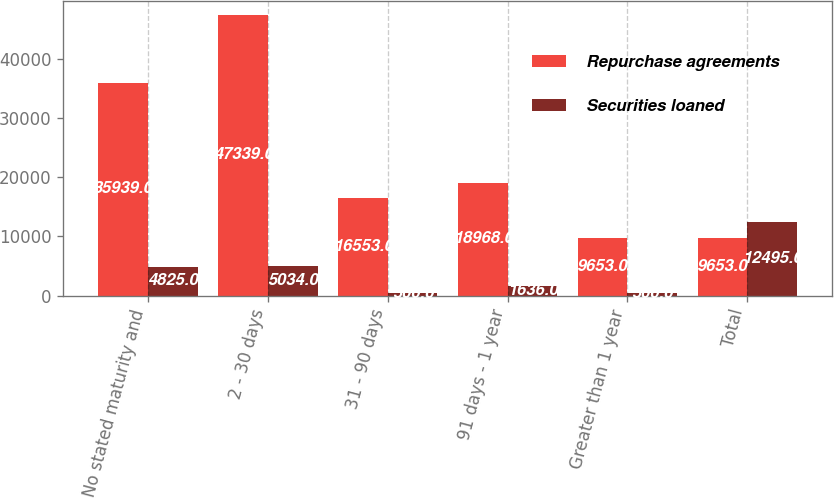Convert chart to OTSL. <chart><loc_0><loc_0><loc_500><loc_500><stacked_bar_chart><ecel><fcel>No stated maturity and<fcel>2 - 30 days<fcel>31 - 90 days<fcel>91 days - 1 year<fcel>Greater than 1 year<fcel>Total<nl><fcel>Repurchase agreements<fcel>35939<fcel>47339<fcel>16553<fcel>18968<fcel>9653<fcel>9653<nl><fcel>Securities loaned<fcel>4825<fcel>5034<fcel>500<fcel>1636<fcel>500<fcel>12495<nl></chart> 